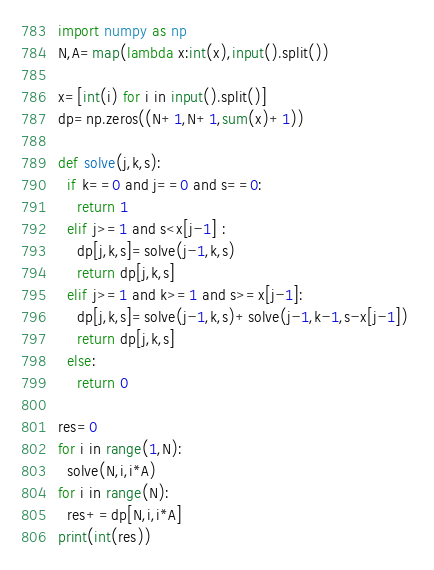<code> <loc_0><loc_0><loc_500><loc_500><_Python_>import numpy as np
N,A=map(lambda x:int(x),input().split())

x=[int(i) for i in input().split()]
dp=np.zeros((N+1,N+1,sum(x)+1))

def solve(j,k,s):
  if k==0 and j==0 and s==0:
    return 1
  elif j>=1 and s<x[j-1] :
    dp[j,k,s]=solve(j-1,k,s)
    return dp[j,k,s]
  elif j>=1 and k>=1 and s>=x[j-1]:
    dp[j,k,s]=solve(j-1,k,s)+solve(j-1,k-1,s-x[j-1]) 
    return dp[j,k,s]
  else:
    return 0

res=0
for i in range(1,N):
  solve(N,i,i*A)
for i in range(N):
  res+=dp[N,i,i*A]
print(int(res))</code> 